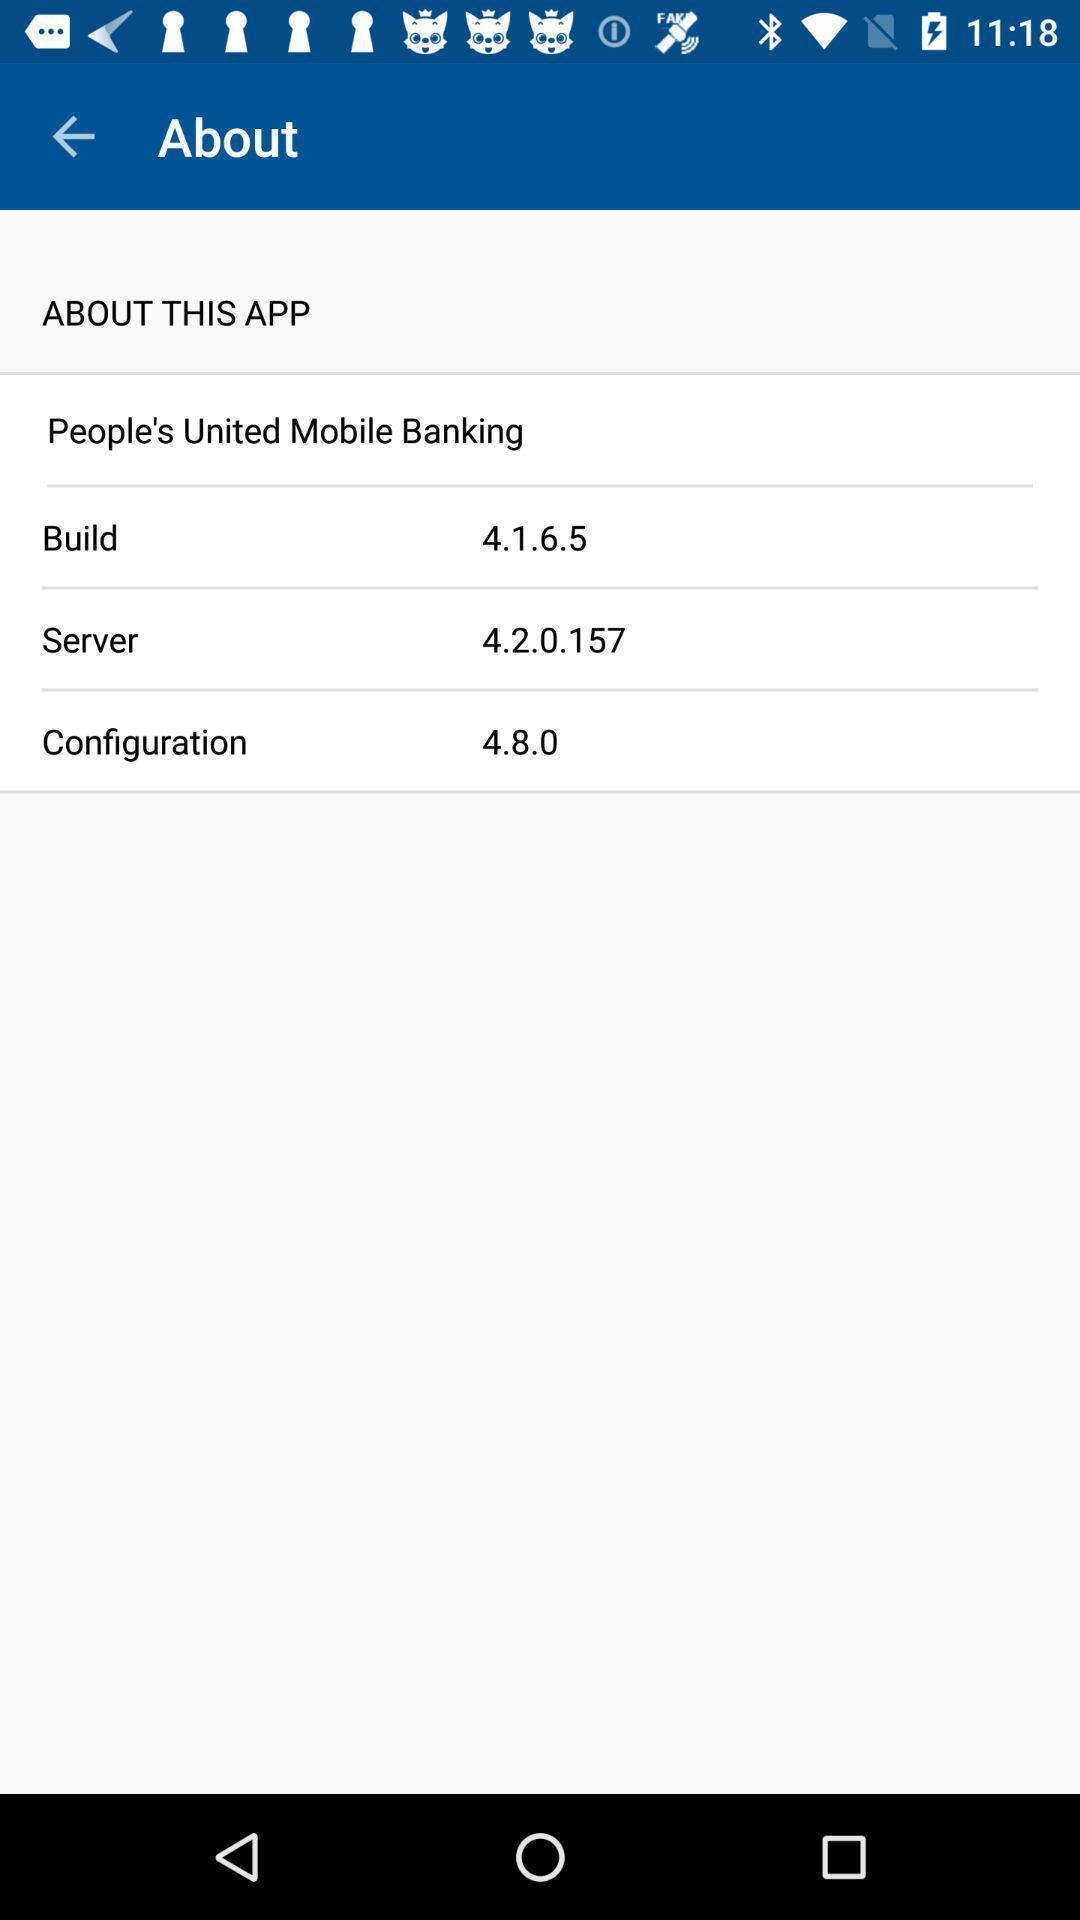What details can you identify in this image? Window displaying about mobile banking app. 